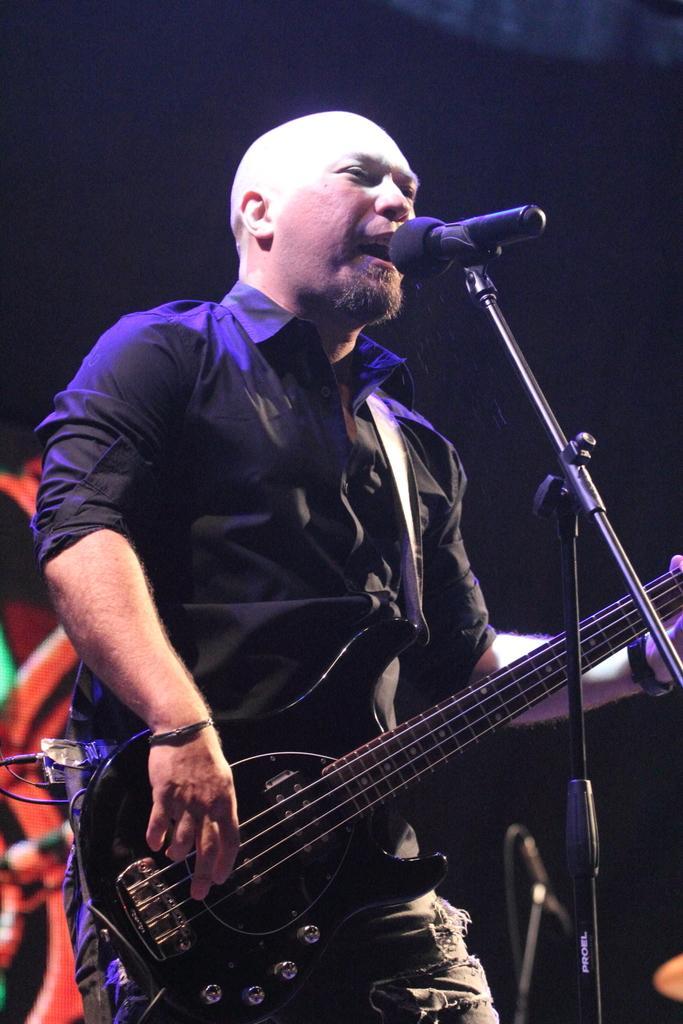Describe this image in one or two sentences. In this picture a man standing. He is singing and playing the guitar. He has a in front of him. He wears a black shirt with torn jeans. 